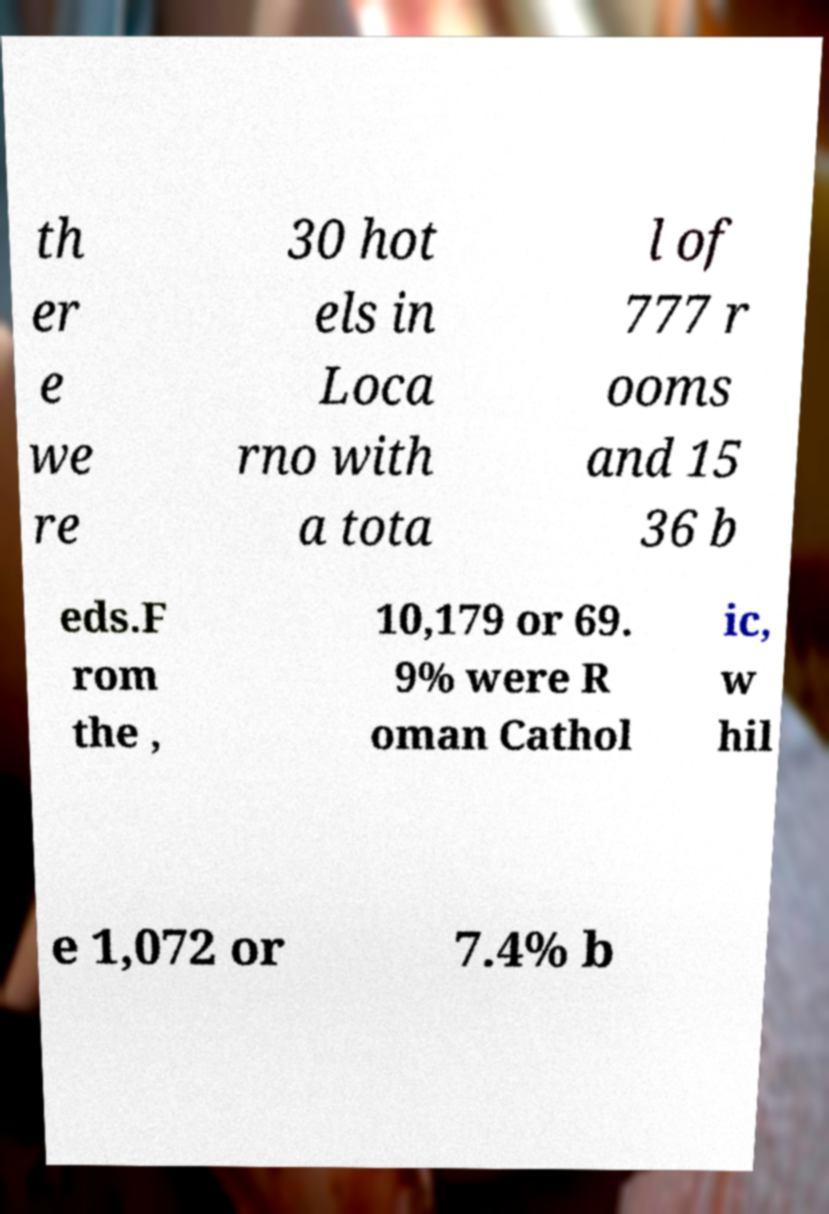I need the written content from this picture converted into text. Can you do that? th er e we re 30 hot els in Loca rno with a tota l of 777 r ooms and 15 36 b eds.F rom the , 10,179 or 69. 9% were R oman Cathol ic, w hil e 1,072 or 7.4% b 